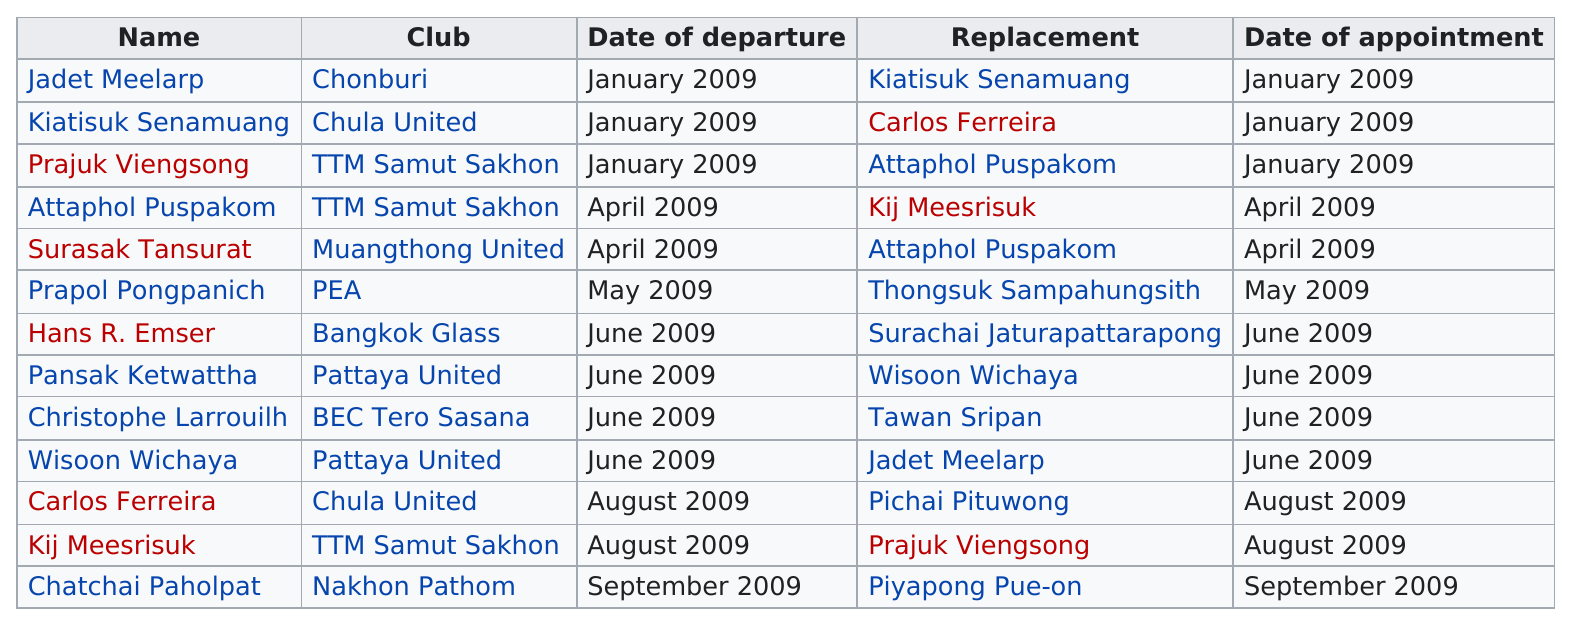Outline some significant characteristics in this image. On June 1, 2009, Hans R. Esmer and Christophe Larrouillh were both replaced in a company. In January, there were three appointments. In 2009, there were 13 managerial changes. Attaphol Puspakom is the name that comes just before Surasak Tansurat on the list. In April 2009, Attaphol Puspakom was chosen as a replacement for Kij Meesrisuk. 